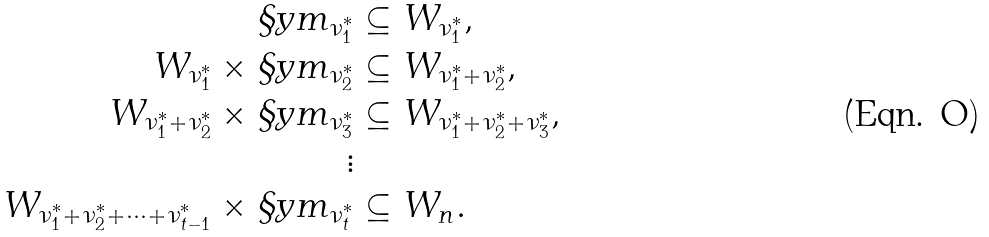<formula> <loc_0><loc_0><loc_500><loc_500>\S y m _ { \nu _ { 1 } ^ { * } } & \subseteq W _ { \nu _ { 1 } ^ { * } } , \\ W _ { \nu _ { 1 } ^ { * } } \times \S y m _ { \nu _ { 2 } ^ { * } } & \subseteq W _ { \nu _ { 1 } ^ { * } + \nu _ { 2 } ^ { * } } , \\ W _ { \nu _ { 1 } ^ { * } + \nu _ { 2 } ^ { * } } \times \S y m _ { \nu _ { 3 } ^ { * } } & \subseteq W _ { \nu _ { 1 } ^ { * } + \nu _ { 2 } ^ { * } + \nu _ { 3 } ^ { * } } , \\ \vdots & \\ W _ { \nu _ { 1 } ^ { * } + \nu _ { 2 } ^ { * } + \cdots + \nu _ { t - 1 } ^ { * } } \times \S y m _ { \nu _ { t } ^ { * } } & \subseteq W _ { n } .</formula> 